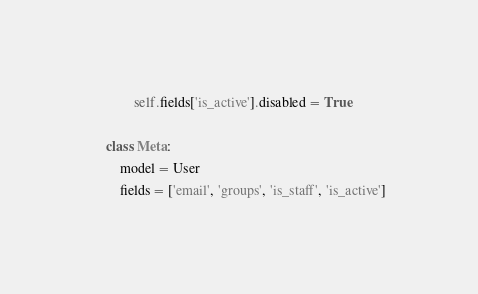Convert code to text. <code><loc_0><loc_0><loc_500><loc_500><_Python_>            self.fields['is_active'].disabled = True

    class Meta:
        model = User
        fields = ['email', 'groups', 'is_staff', 'is_active']
</code> 